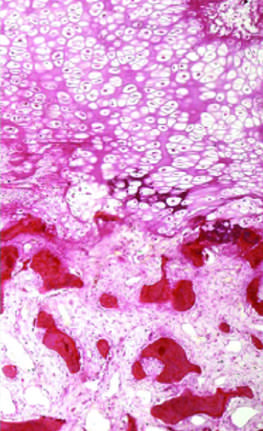what consists of uncalcified osteoid?
Answer the question using a single word or phrase. Paler trabeculae 